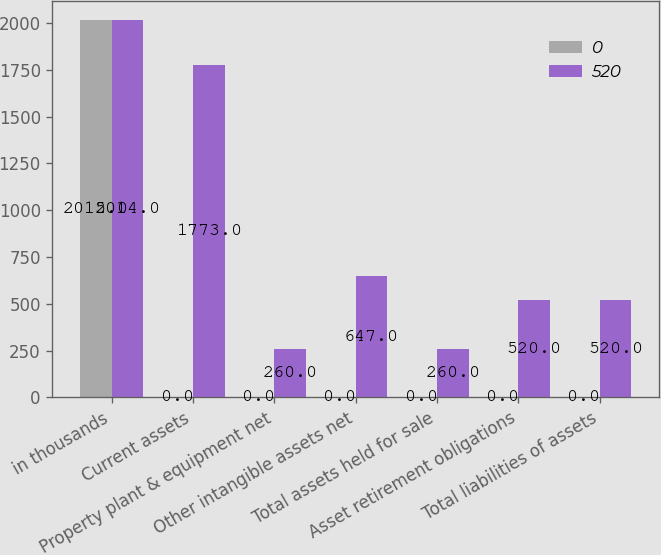<chart> <loc_0><loc_0><loc_500><loc_500><stacked_bar_chart><ecel><fcel>in thousands<fcel>Current assets<fcel>Property plant & equipment net<fcel>Other intangible assets net<fcel>Total assets held for sale<fcel>Asset retirement obligations<fcel>Total liabilities of assets<nl><fcel>0<fcel>2015<fcel>0<fcel>0<fcel>0<fcel>0<fcel>0<fcel>0<nl><fcel>520<fcel>2014<fcel>1773<fcel>260<fcel>647<fcel>260<fcel>520<fcel>520<nl></chart> 